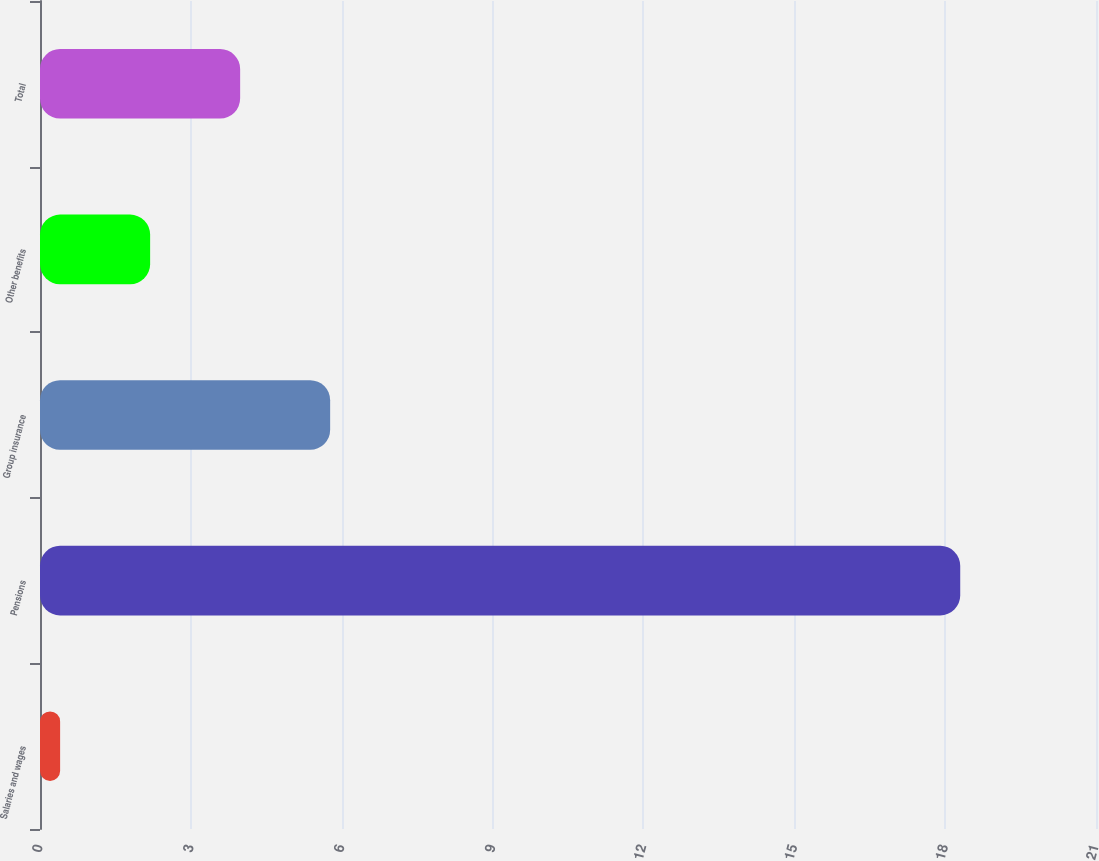<chart> <loc_0><loc_0><loc_500><loc_500><bar_chart><fcel>Salaries and wages<fcel>Pensions<fcel>Group insurance<fcel>Other benefits<fcel>Total<nl><fcel>0.4<fcel>18.3<fcel>5.77<fcel>2.19<fcel>3.98<nl></chart> 